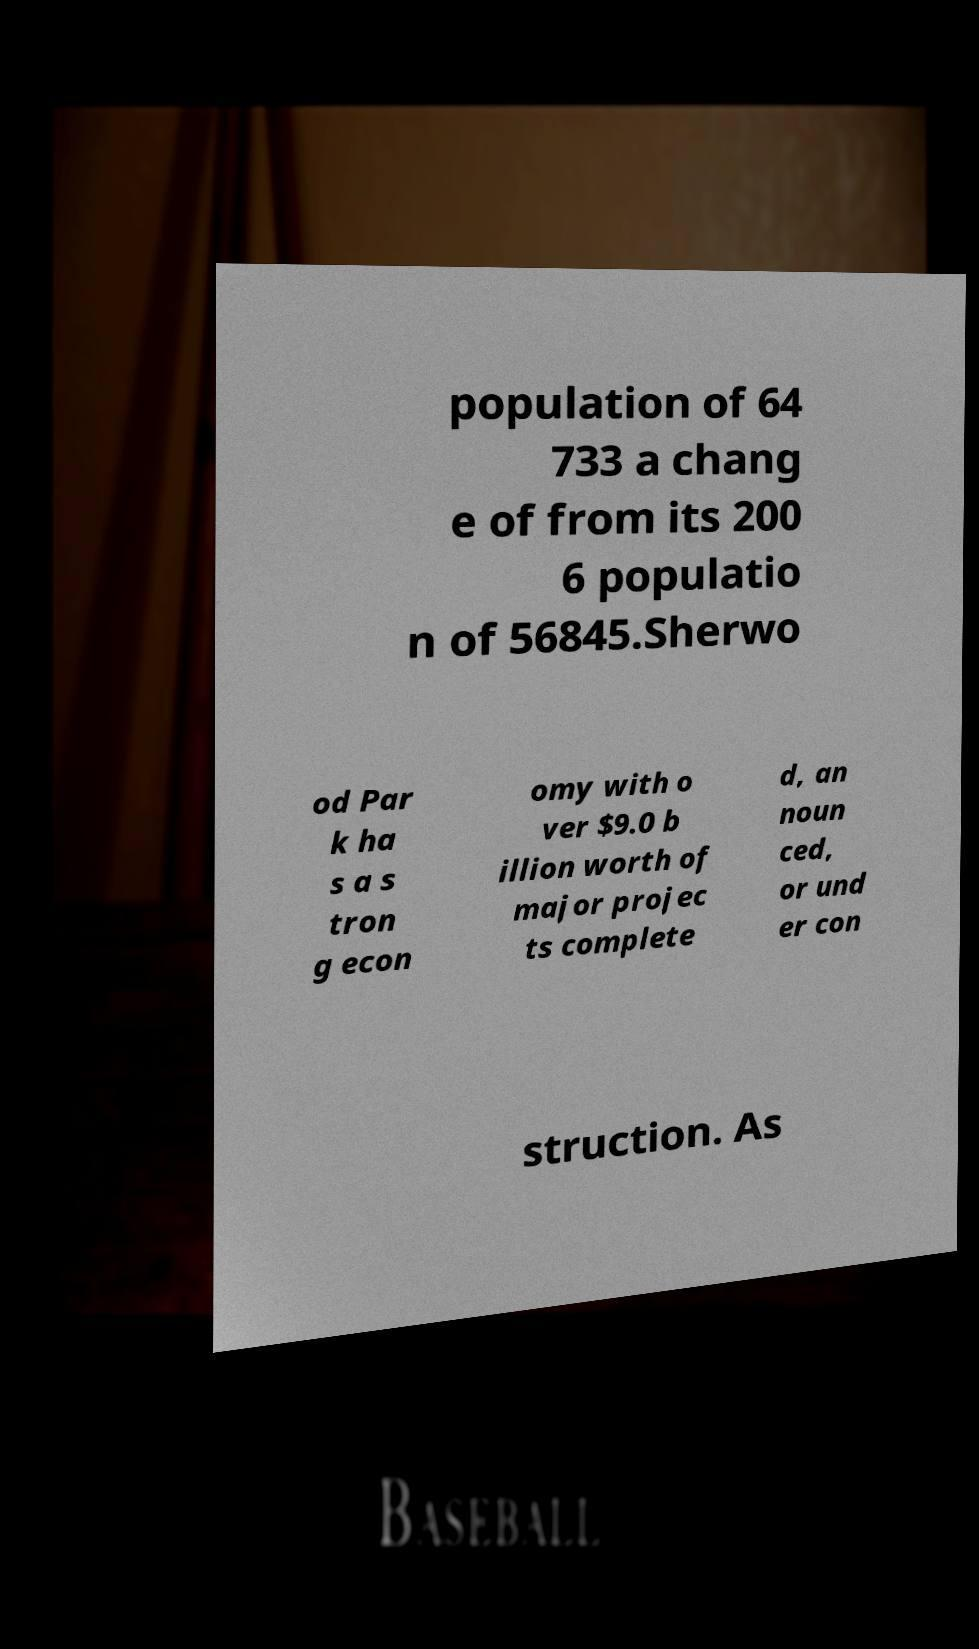Can you read and provide the text displayed in the image?This photo seems to have some interesting text. Can you extract and type it out for me? population of 64 733 a chang e of from its 200 6 populatio n of 56845.Sherwo od Par k ha s a s tron g econ omy with o ver $9.0 b illion worth of major projec ts complete d, an noun ced, or und er con struction. As 